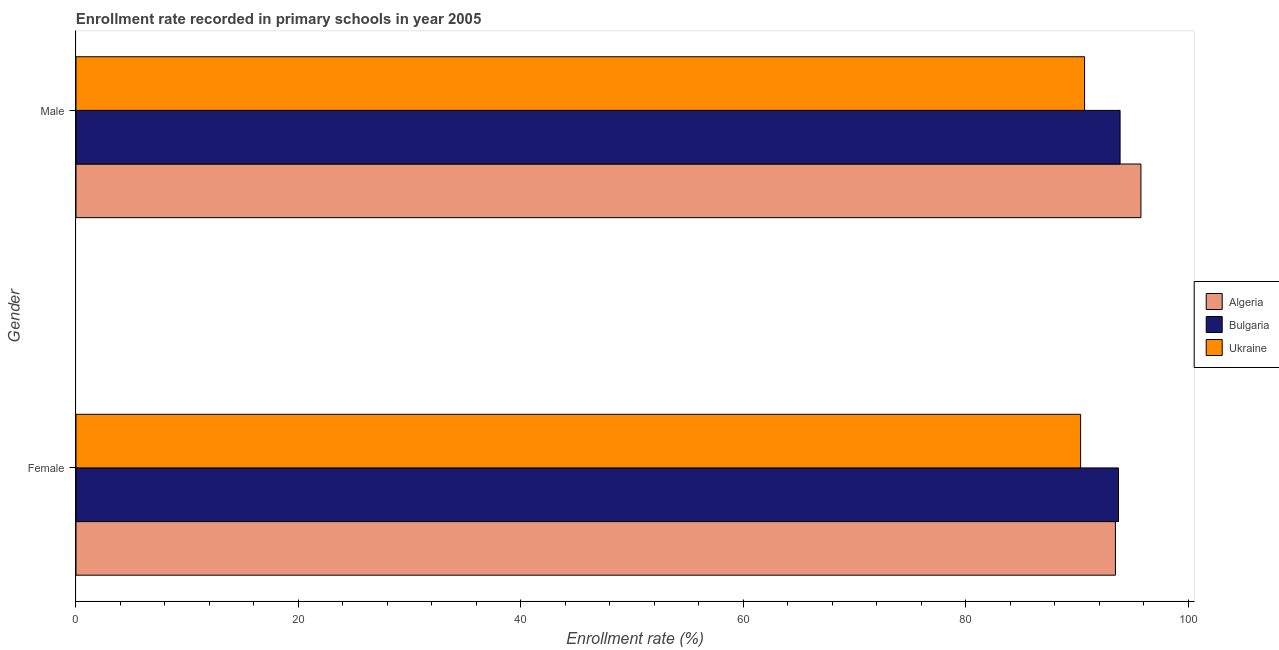How many different coloured bars are there?
Give a very brief answer. 3. Are the number of bars per tick equal to the number of legend labels?
Give a very brief answer. Yes. Are the number of bars on each tick of the Y-axis equal?
Keep it short and to the point. Yes. What is the label of the 1st group of bars from the top?
Your answer should be very brief. Male. What is the enrollment rate of female students in Algeria?
Your answer should be very brief. 93.45. Across all countries, what is the maximum enrollment rate of female students?
Make the answer very short. 93.73. Across all countries, what is the minimum enrollment rate of male students?
Provide a succinct answer. 90.68. In which country was the enrollment rate of female students maximum?
Your answer should be very brief. Bulgaria. In which country was the enrollment rate of female students minimum?
Provide a succinct answer. Ukraine. What is the total enrollment rate of female students in the graph?
Provide a short and direct response. 277.51. What is the difference between the enrollment rate of female students in Ukraine and that in Algeria?
Your response must be concise. -3.13. What is the difference between the enrollment rate of female students in Ukraine and the enrollment rate of male students in Algeria?
Your response must be concise. -5.42. What is the average enrollment rate of male students per country?
Provide a short and direct response. 93.43. What is the difference between the enrollment rate of male students and enrollment rate of female students in Bulgaria?
Your response must be concise. 0.14. In how many countries, is the enrollment rate of female students greater than 40 %?
Ensure brevity in your answer.  3. What is the ratio of the enrollment rate of male students in Bulgaria to that in Ukraine?
Your answer should be compact. 1.04. Is the enrollment rate of male students in Algeria less than that in Bulgaria?
Ensure brevity in your answer.  No. In how many countries, is the enrollment rate of male students greater than the average enrollment rate of male students taken over all countries?
Your answer should be compact. 2. What does the 1st bar from the top in Male represents?
Keep it short and to the point. Ukraine. What does the 2nd bar from the bottom in Female represents?
Ensure brevity in your answer.  Bulgaria. Are the values on the major ticks of X-axis written in scientific E-notation?
Provide a succinct answer. No. Does the graph contain any zero values?
Provide a succinct answer. No. How are the legend labels stacked?
Keep it short and to the point. Vertical. What is the title of the graph?
Provide a short and direct response. Enrollment rate recorded in primary schools in year 2005. Does "Canada" appear as one of the legend labels in the graph?
Offer a terse response. No. What is the label or title of the X-axis?
Give a very brief answer. Enrollment rate (%). What is the label or title of the Y-axis?
Your answer should be very brief. Gender. What is the Enrollment rate (%) of Algeria in Female?
Provide a short and direct response. 93.45. What is the Enrollment rate (%) in Bulgaria in Female?
Provide a succinct answer. 93.73. What is the Enrollment rate (%) in Ukraine in Female?
Offer a terse response. 90.32. What is the Enrollment rate (%) of Algeria in Male?
Ensure brevity in your answer.  95.75. What is the Enrollment rate (%) of Bulgaria in Male?
Offer a very short reply. 93.87. What is the Enrollment rate (%) of Ukraine in Male?
Provide a succinct answer. 90.68. Across all Gender, what is the maximum Enrollment rate (%) in Algeria?
Your answer should be very brief. 95.75. Across all Gender, what is the maximum Enrollment rate (%) of Bulgaria?
Provide a short and direct response. 93.87. Across all Gender, what is the maximum Enrollment rate (%) in Ukraine?
Ensure brevity in your answer.  90.68. Across all Gender, what is the minimum Enrollment rate (%) in Algeria?
Offer a very short reply. 93.45. Across all Gender, what is the minimum Enrollment rate (%) in Bulgaria?
Provide a succinct answer. 93.73. Across all Gender, what is the minimum Enrollment rate (%) of Ukraine?
Ensure brevity in your answer.  90.32. What is the total Enrollment rate (%) of Algeria in the graph?
Give a very brief answer. 189.2. What is the total Enrollment rate (%) in Bulgaria in the graph?
Provide a succinct answer. 187.6. What is the total Enrollment rate (%) of Ukraine in the graph?
Your response must be concise. 181. What is the difference between the Enrollment rate (%) in Algeria in Female and that in Male?
Provide a succinct answer. -2.29. What is the difference between the Enrollment rate (%) of Bulgaria in Female and that in Male?
Your answer should be very brief. -0.14. What is the difference between the Enrollment rate (%) in Ukraine in Female and that in Male?
Provide a short and direct response. -0.35. What is the difference between the Enrollment rate (%) in Algeria in Female and the Enrollment rate (%) in Bulgaria in Male?
Your answer should be very brief. -0.42. What is the difference between the Enrollment rate (%) of Algeria in Female and the Enrollment rate (%) of Ukraine in Male?
Make the answer very short. 2.78. What is the difference between the Enrollment rate (%) in Bulgaria in Female and the Enrollment rate (%) in Ukraine in Male?
Give a very brief answer. 3.05. What is the average Enrollment rate (%) of Algeria per Gender?
Your answer should be very brief. 94.6. What is the average Enrollment rate (%) in Bulgaria per Gender?
Your response must be concise. 93.8. What is the average Enrollment rate (%) of Ukraine per Gender?
Your answer should be compact. 90.5. What is the difference between the Enrollment rate (%) in Algeria and Enrollment rate (%) in Bulgaria in Female?
Your answer should be compact. -0.28. What is the difference between the Enrollment rate (%) in Algeria and Enrollment rate (%) in Ukraine in Female?
Offer a very short reply. 3.13. What is the difference between the Enrollment rate (%) of Bulgaria and Enrollment rate (%) of Ukraine in Female?
Ensure brevity in your answer.  3.4. What is the difference between the Enrollment rate (%) in Algeria and Enrollment rate (%) in Bulgaria in Male?
Offer a terse response. 1.88. What is the difference between the Enrollment rate (%) of Algeria and Enrollment rate (%) of Ukraine in Male?
Keep it short and to the point. 5.07. What is the difference between the Enrollment rate (%) of Bulgaria and Enrollment rate (%) of Ukraine in Male?
Offer a very short reply. 3.19. What is the difference between the highest and the second highest Enrollment rate (%) in Algeria?
Provide a succinct answer. 2.29. What is the difference between the highest and the second highest Enrollment rate (%) in Bulgaria?
Offer a very short reply. 0.14. What is the difference between the highest and the second highest Enrollment rate (%) in Ukraine?
Ensure brevity in your answer.  0.35. What is the difference between the highest and the lowest Enrollment rate (%) in Algeria?
Offer a terse response. 2.29. What is the difference between the highest and the lowest Enrollment rate (%) of Bulgaria?
Ensure brevity in your answer.  0.14. What is the difference between the highest and the lowest Enrollment rate (%) in Ukraine?
Your answer should be compact. 0.35. 